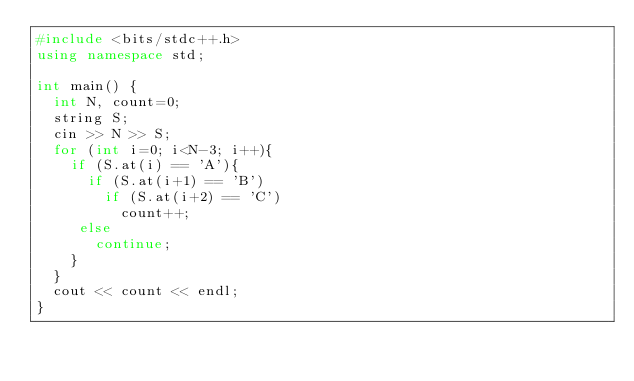<code> <loc_0><loc_0><loc_500><loc_500><_C++_>#include <bits/stdc++.h>
using namespace std;
 
int main() {
  int N, count=0;
  string S;
  cin >> N >> S; 
  for (int i=0; i<N-3; i++){
    if (S.at(i) == 'A'){
      if (S.at(i+1) == 'B')
        if (S.at(i+2) == 'C')
          count++;
     else
       continue;
    }
  }
  cout << count << endl;
}</code> 